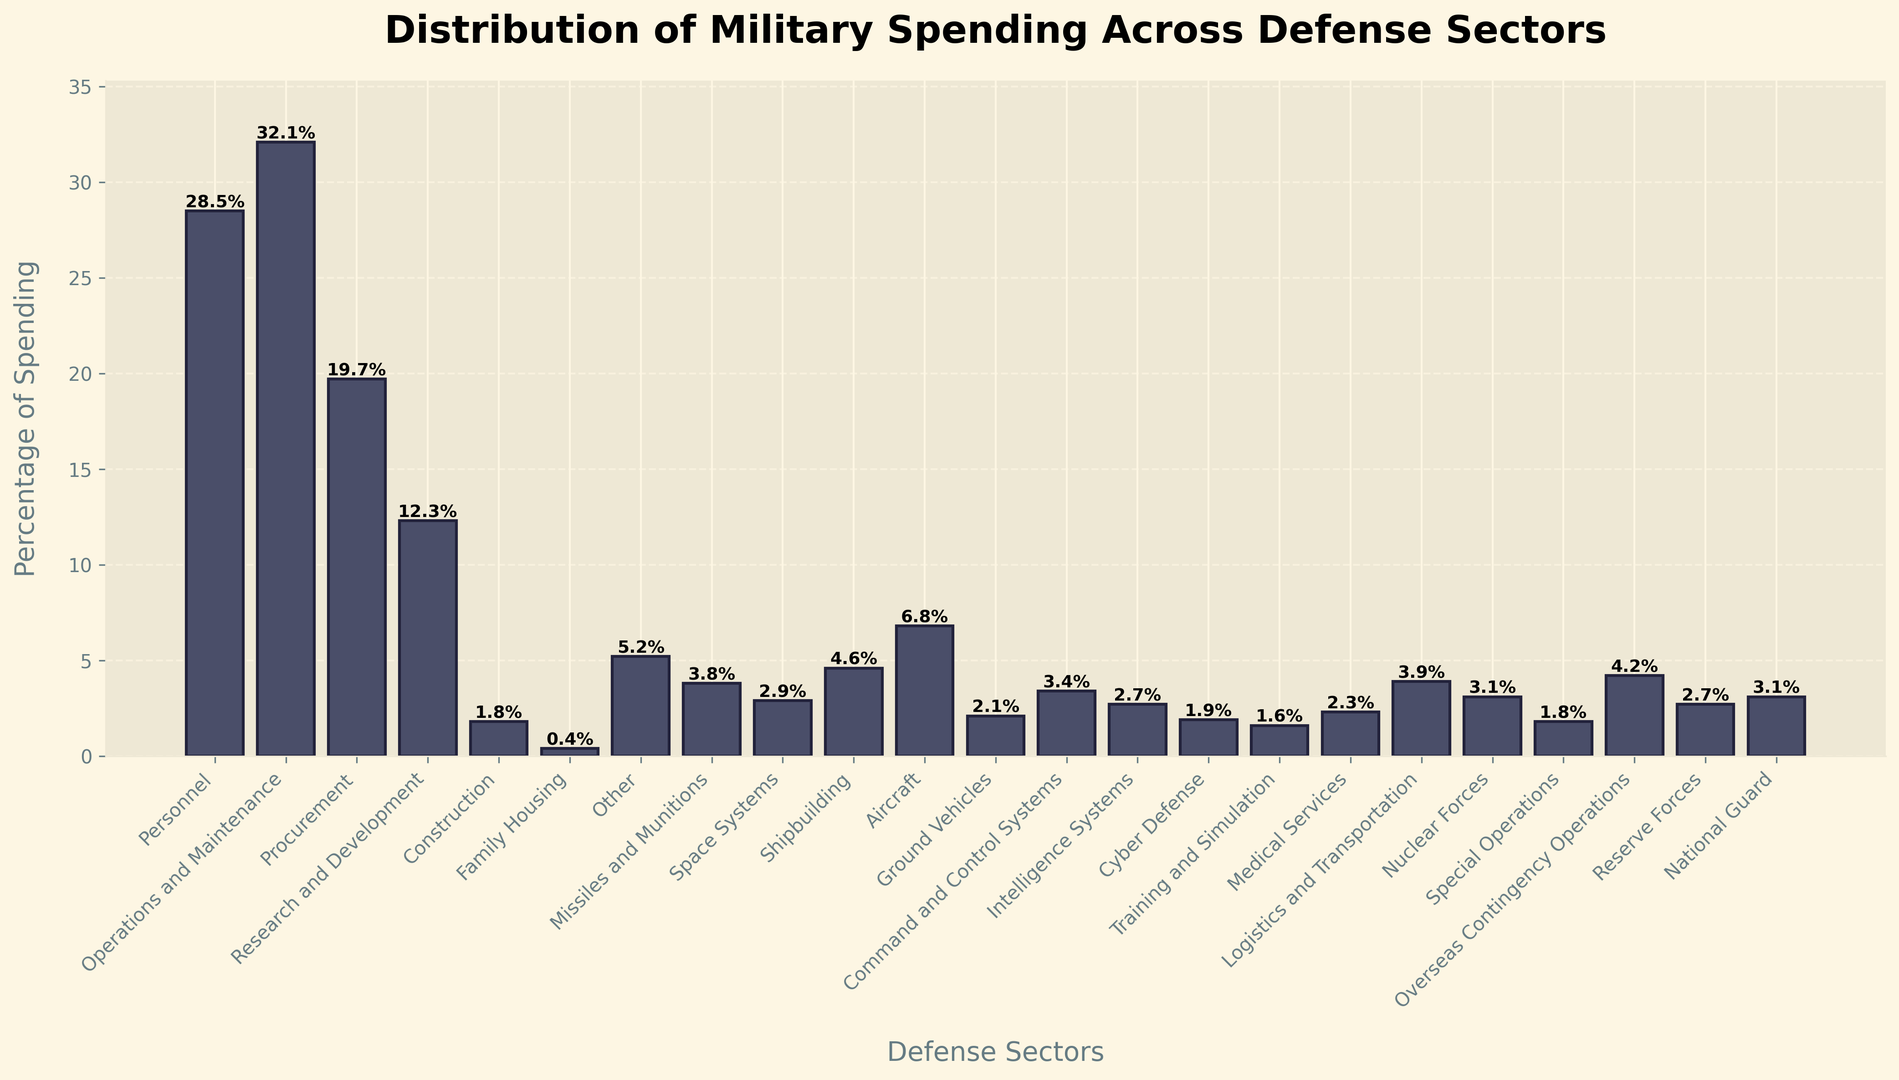Which defense sector has the highest percentage of spending? The highest percentage spending is visually the tallest bar, which corresponds to Operations and Maintenance.
Answer: Operations and Maintenance Which defense sectors have a spending percentage greater than 10%? By identifying the bars that exceed the 10% mark on the y-axis, we see that Personnel, Operations and Maintenance, Procurement, and Research and Development surpass 10%.
Answer: Personnel, Operations and Maintenance, Procurement, Research and Development What is the total percentage of spending in Personnel, Operations and Maintenance, and Procurement combined? Summing the values: Personnel (28.5%) + Operations and Maintenance (32.1%) + Procurement (19.7%) results in 28.5 + 32.1 + 19.7 = 80.3%.
Answer: 80.3% How does the spending percentage in Space Systems compare to that in Missiles and Munitions? Space Systems have a spending percentage of 2.9%, while Missiles and Munitions have 3.8%. The bar for Missiles and Munitions is taller, meaning it has a higher percentage.
Answer: Missiles and Munitions have a higher percentage Which two sectors have the lowest spending percentages? The shortest bars indicate the smallest percentages, which are Family Housing (0.4%) and Training and Simulation (1.6%).
Answer: Family Housing, Training and Simulation What is the difference in spending percentage between Aircraft and Ground Vehicles? Aircraft has a spending percentage of 6.8% and Ground Vehicles have 2.1%. The difference is 6.8 - 2.1 = 4.7%.
Answer: 4.7% What is the combined spending percentage for Medical Services and Logistics and Transportation? Medical Services is 2.3% and Logistics and Transportation is 3.9%. Adding them together, 2.3 + 3.9 = 6.2%.
Answer: 6.2% Is the spending on Nuclear Forces higher or lower than that on Cyber Defense? Nuclear Forces have a percentage of 3.1%, while Cyber Defense stands at 1.9%. The bar for Nuclear Forces is taller, indicating higher spending.
Answer: Higher What is the average spending percentage for Intelligence Systems, Command and Control Systems, and Cyber Defense? Summing Intelligence Systems (2.7%), Command and Control Systems (3.4%), and Cyber Defense (1.9%) gives 2.7 + 3.4 + 1.9 = 8.0%. Dividing by 3 yields 8.0 / 3 = 2.67%.
Answer: 2.67% What percentage more is spent on Operations and Maintenance compared to Construction? Operations and Maintenance has a percentage of 32.1%, and Construction has 1.8%. The difference is 32.1 - 1.8 = 30.3%.
Answer: 30.3% 